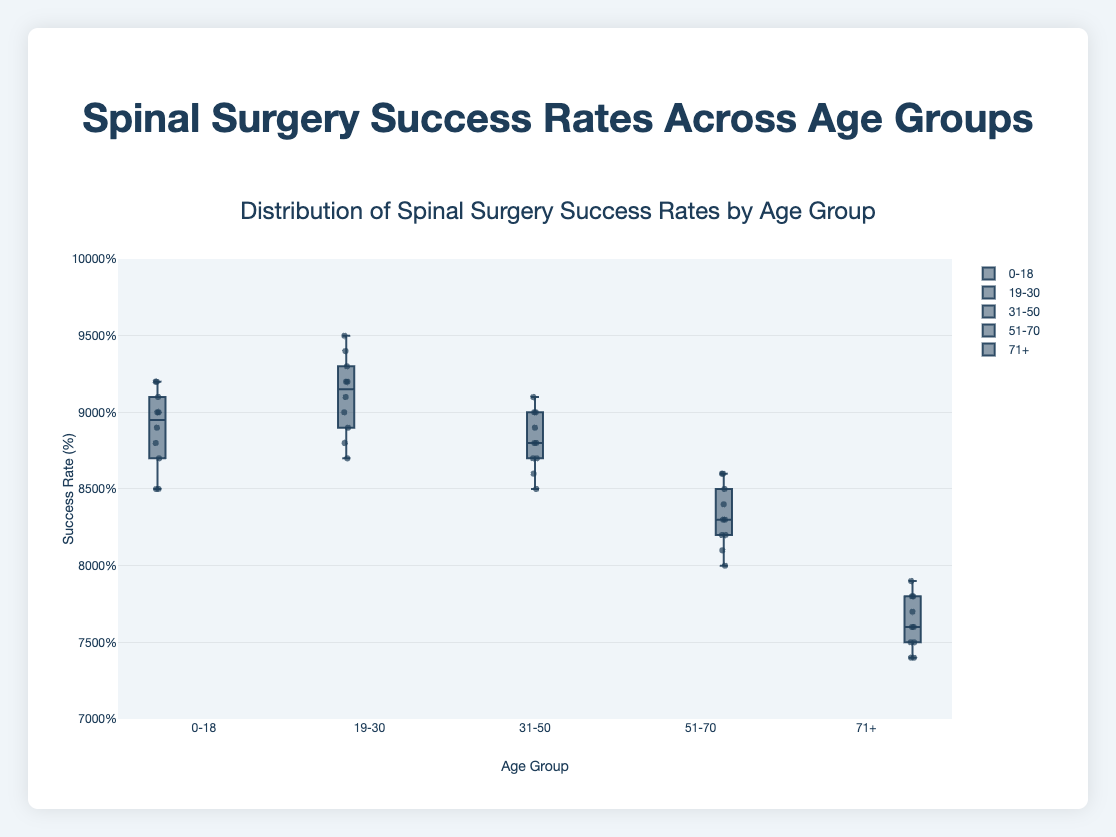What is the title of the figure? The title of a figure is usually at the top of the diagram and describes what the graph is about. In this case, the title of the figure is "Distribution of Spinal Surgery Success Rates by Age Group".
Answer: Distribution of Spinal Surgery Success Rates by Age Group What is the y-axis representing in this box plot? The y-axis in this box plot is labeled "Success Rate (%)", which means it represents the percentages of success rates of spinal surgeries.
Answer: Success Rate (%) What age group shows the highest median success rate in spinal surgeries? In a box plot, the median value is marked by the line inside the box. By looking at the boxes, the age group "19-30" has the highest median line compared to other age groups.
Answer: 19-30 Which age group has the lowest overall spread in success rates? The spread in a box plot is indicated by the range between the minimum and maximum whiskers. By observing the plots, "31-50" has the shortest distance between its whiskers and therefore the smallest spread.
Answer: 31-50 For the age group "0-18", what is the median success rate? The median success rate is represented by the line inside the box for each age group. For "0-18", the median line appears at 90%, indicating the median success rate.
Answer: 90% Compare the success rates between the "51-70" and "71+" age groups. Which one has a higher median, and by how much? The median can be identified by the line in the middle of the box. "51-70" has a median around 83%, while "71+" has a median around 76%. To find the difference: 83% - 76% = 7%.
Answer: 51-70 by 7% Which age group shows the widest range of success rates, and what is this range? The widest range can be determined by looking at the length of the whiskers. The age group "71+" shows the longest whiskers, spreading from around 74% to 79%. The range is the difference between these values: 79% - 74% = 5%.
Answer: 71+, 5% How many data points are plotted for each age group? This can be found by either counting the number of individual data points plotted within each box or referring to the provided data. Each age group has 10 data points as per the given dataset.
Answer: 10 Is there any age group with an outlier? Explain your answer. Outliers in a box plot are usually marked with individual points outside the whiskers. By examining the plots, none of the age groups have points outside their respective whiskers, so there are no outliers in any age group.
Answer: No Based on the box plot, which age group seems to have the most consistent success rate, and why? Consistency can be inferred from a smaller interquartile range (IQR), which is the box's height. The "19-30" age group shows a smaller IQR compared to the others, indicating a more consistent success rate.
Answer: 19-30 